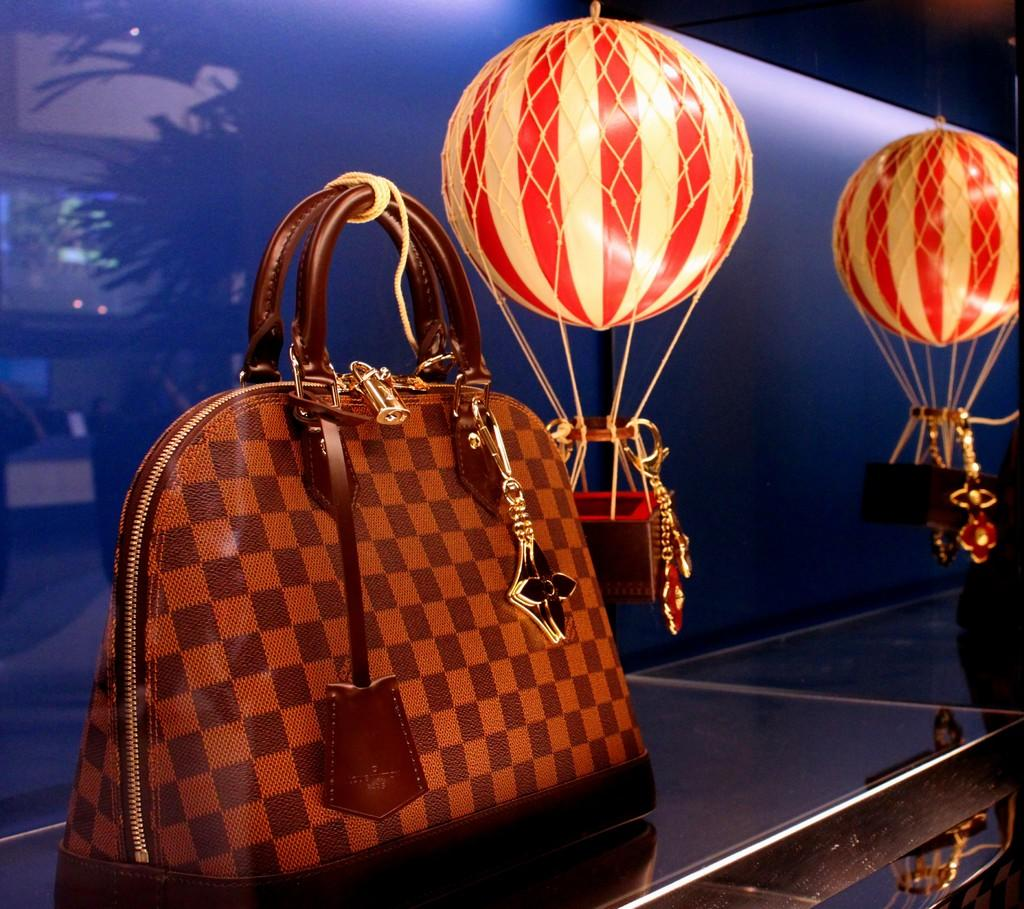What object can be seen in the image? There is a handbag in the image. What decorative items are hanging from the ceiling in the image? There are small parachutes hanging from the ceiling in the image. What type of coat is being worn by the person in the image? There is no person visible in the image, so it is not possible to determine what type of coat they might be wearing. 